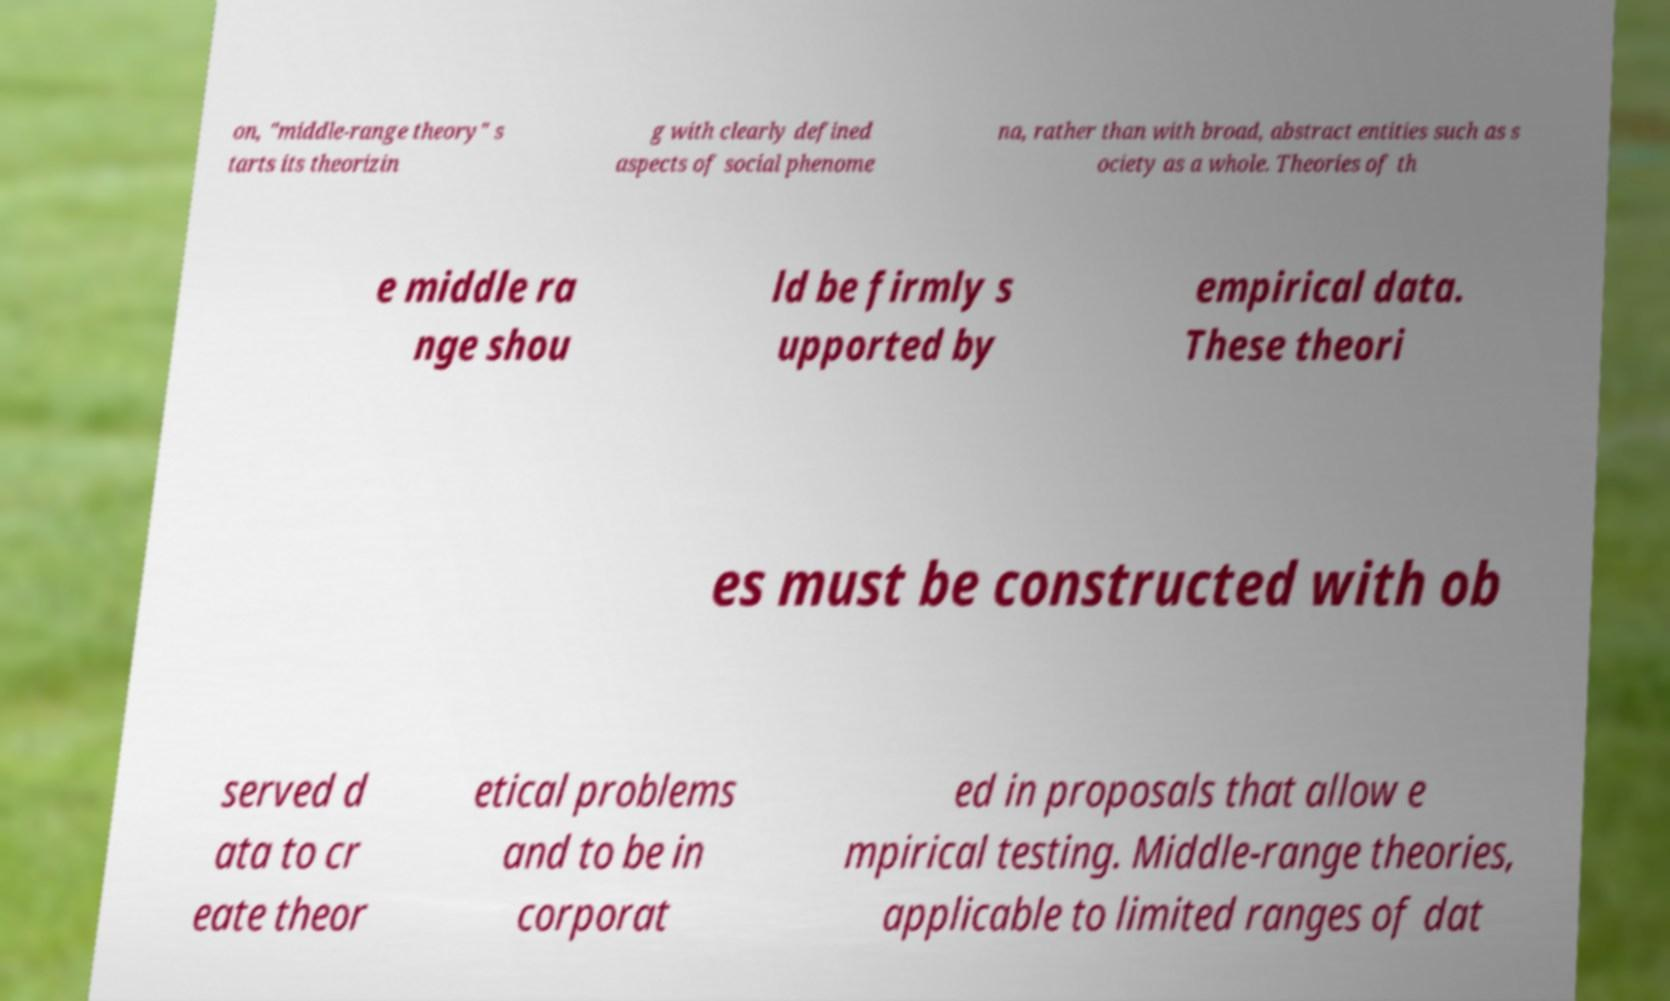There's text embedded in this image that I need extracted. Can you transcribe it verbatim? on, "middle-range theory" s tarts its theorizin g with clearly defined aspects of social phenome na, rather than with broad, abstract entities such as s ociety as a whole. Theories of th e middle ra nge shou ld be firmly s upported by empirical data. These theori es must be constructed with ob served d ata to cr eate theor etical problems and to be in corporat ed in proposals that allow e mpirical testing. Middle-range theories, applicable to limited ranges of dat 